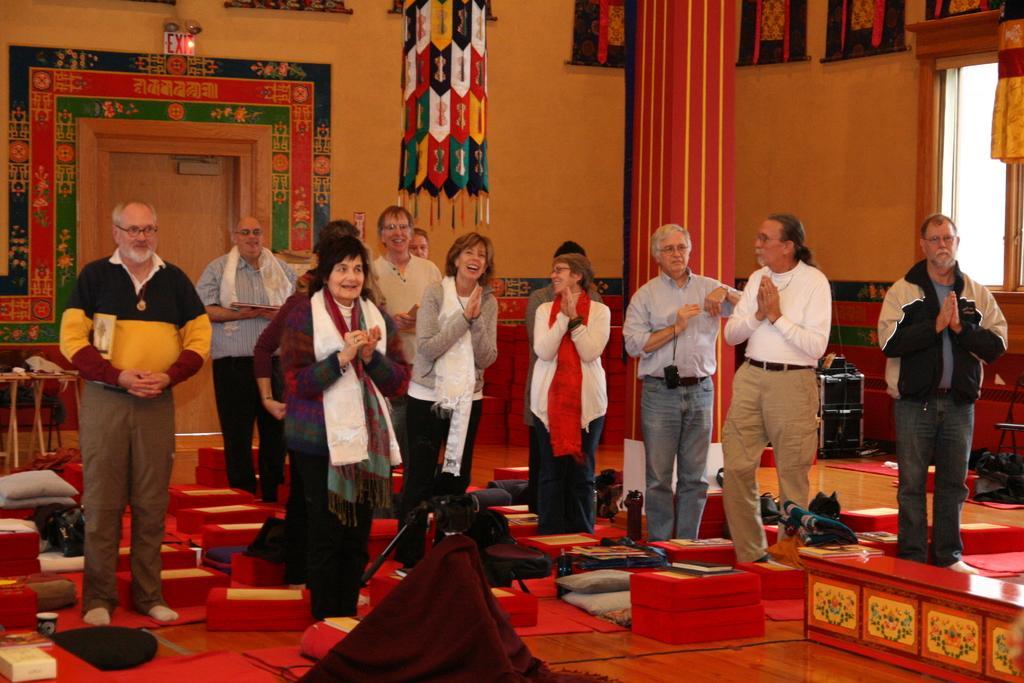In one or two sentences, can you explain what this image depicts? In this image there are people. There are boxes. There is a wall. We can see wall hangers and posters. 